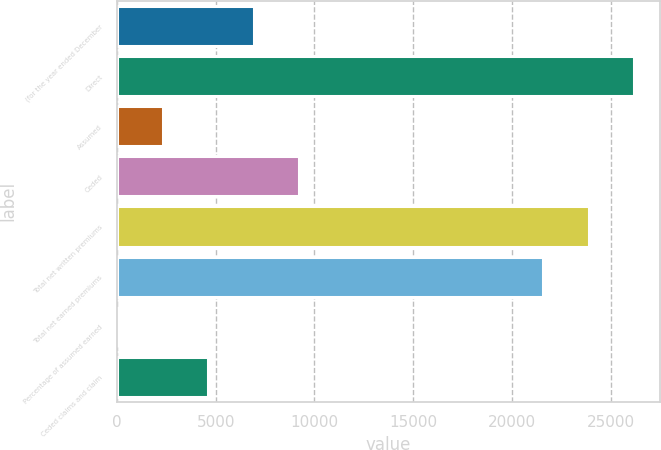Convert chart to OTSL. <chart><loc_0><loc_0><loc_500><loc_500><bar_chart><fcel>(for the year ended December<fcel>Direct<fcel>Assumed<fcel>Ceded<fcel>Total net written premiums<fcel>Total net earned premiums<fcel>Percentage of assumed earned<fcel>Ceded claims and claim<nl><fcel>6924.72<fcel>26193.1<fcel>2310.64<fcel>9231.76<fcel>23886<fcel>21579<fcel>3.6<fcel>4617.68<nl></chart> 